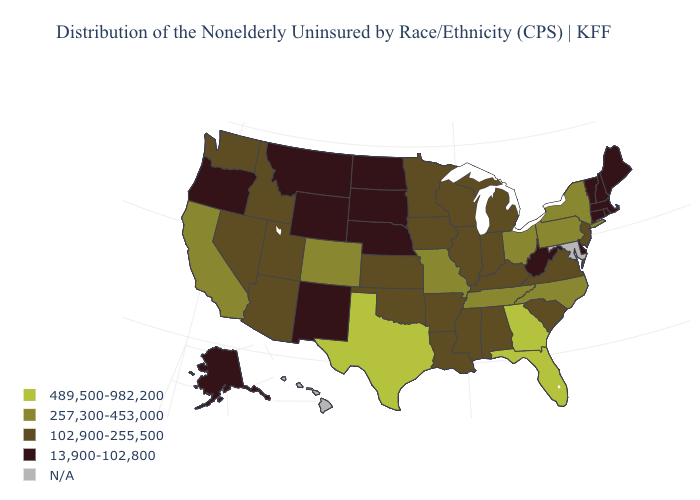Name the states that have a value in the range 13,900-102,800?
Write a very short answer. Alaska, Connecticut, Delaware, Maine, Massachusetts, Montana, Nebraska, New Hampshire, New Mexico, North Dakota, Oregon, Rhode Island, South Dakota, Vermont, West Virginia, Wyoming. What is the value of Texas?
Write a very short answer. 489,500-982,200. What is the value of Vermont?
Answer briefly. 13,900-102,800. Name the states that have a value in the range 13,900-102,800?
Be succinct. Alaska, Connecticut, Delaware, Maine, Massachusetts, Montana, Nebraska, New Hampshire, New Mexico, North Dakota, Oregon, Rhode Island, South Dakota, Vermont, West Virginia, Wyoming. Name the states that have a value in the range N/A?
Quick response, please. Hawaii, Maryland. What is the lowest value in the South?
Answer briefly. 13,900-102,800. What is the highest value in states that border Illinois?
Short answer required. 257,300-453,000. Among the states that border Montana , which have the highest value?
Write a very short answer. Idaho. Name the states that have a value in the range N/A?
Answer briefly. Hawaii, Maryland. Name the states that have a value in the range 489,500-982,200?
Quick response, please. Florida, Georgia, Texas. Is the legend a continuous bar?
Be succinct. No. Does Maine have the highest value in the USA?
Be succinct. No. What is the lowest value in states that border Wisconsin?
Quick response, please. 102,900-255,500. 